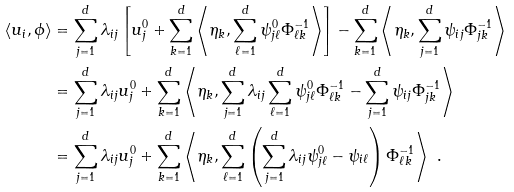Convert formula to latex. <formula><loc_0><loc_0><loc_500><loc_500>\langle u _ { i } , \phi \rangle & = \sum _ { j = 1 } ^ { d } \lambda _ { i j } \left [ u ^ { 0 } _ { j } + \sum _ { k = 1 } ^ { d } \left \langle \eta _ { k } , \sum _ { \ell = 1 } ^ { d } \psi _ { j \ell } ^ { 0 } \Phi _ { \ell k } ^ { - 1 } \right \rangle \right ] - \sum _ { k = 1 } ^ { d } \left \langle \eta _ { k } , \sum _ { j = 1 } ^ { d } \psi _ { i j } \Phi _ { j k } ^ { - 1 } \right \rangle \\ & = \sum _ { j = 1 } ^ { d } \lambda _ { i j } u ^ { 0 } _ { j } + \sum _ { k = 1 } ^ { d } \left \langle \eta _ { k } , \sum _ { j = 1 } ^ { d } \lambda _ { i j } \sum _ { \ell = 1 } ^ { d } \psi _ { j \ell } ^ { 0 } \Phi _ { \ell k } ^ { - 1 } - \sum _ { j = 1 } ^ { d } \psi _ { i j } \Phi _ { j k } ^ { - 1 } \right \rangle \\ & = \sum _ { j = 1 } ^ { d } \lambda _ { i j } u ^ { 0 } _ { j } + \sum _ { k = 1 } ^ { d } \left \langle \eta _ { k } , \sum _ { \ell = 1 } ^ { d } \left ( \sum _ { j = 1 } ^ { d } \lambda _ { i j } \psi _ { j \ell } ^ { 0 } - \psi _ { i \ell } \right ) \Phi _ { \ell k } ^ { - 1 } \right \rangle \ .</formula> 